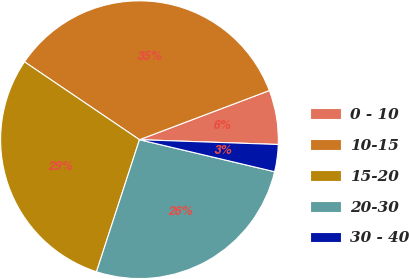Convert chart to OTSL. <chart><loc_0><loc_0><loc_500><loc_500><pie_chart><fcel>0 - 10<fcel>10-15<fcel>15-20<fcel>20-30<fcel>30 - 40<nl><fcel>6.31%<fcel>34.77%<fcel>29.47%<fcel>26.31%<fcel>3.15%<nl></chart> 